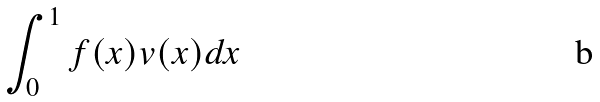<formula> <loc_0><loc_0><loc_500><loc_500>\int _ { 0 } ^ { 1 } f ( x ) v ( x ) d x</formula> 